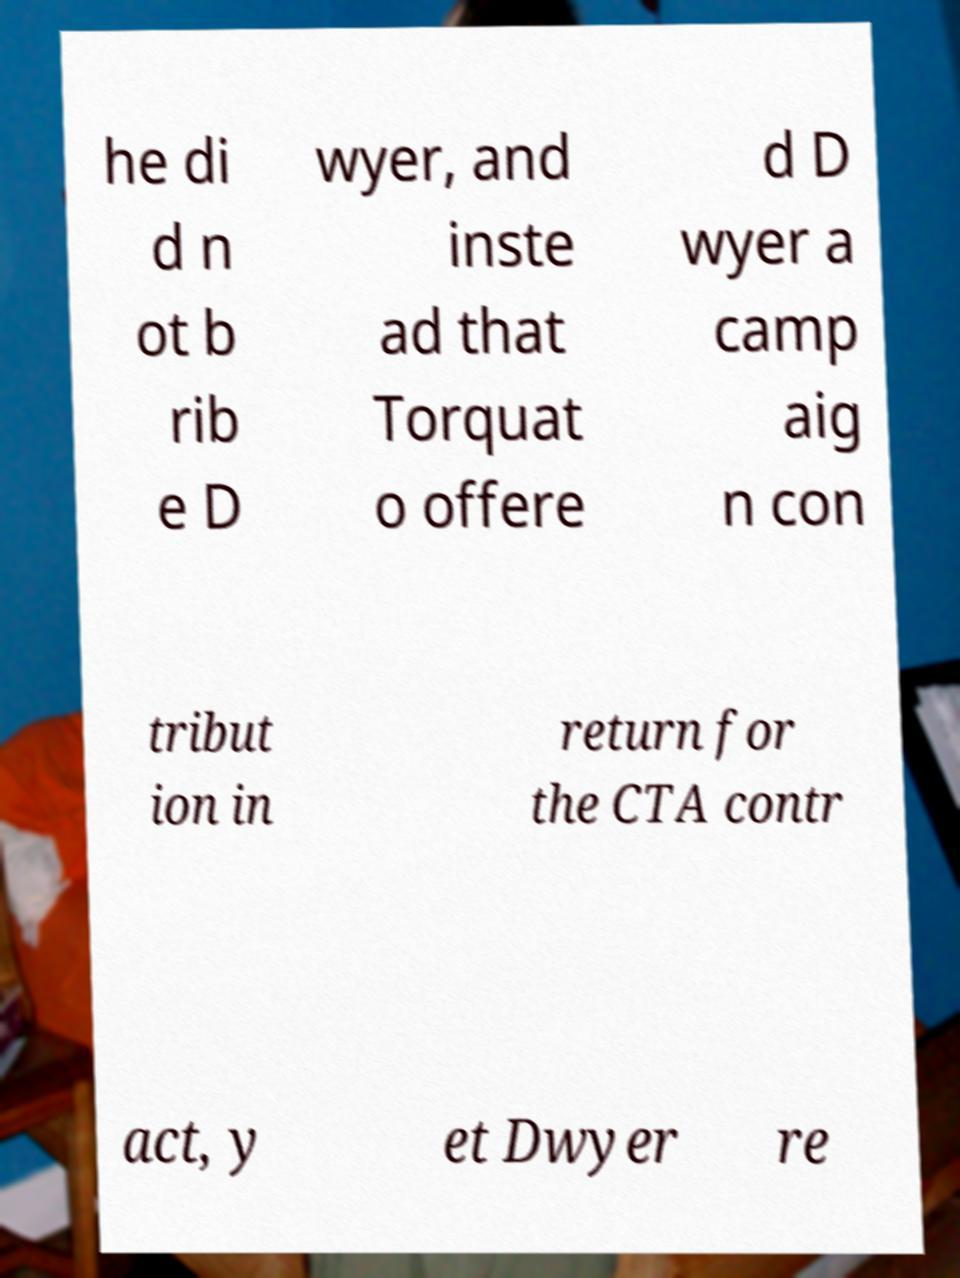Can you accurately transcribe the text from the provided image for me? he di d n ot b rib e D wyer, and inste ad that Torquat o offere d D wyer a camp aig n con tribut ion in return for the CTA contr act, y et Dwyer re 